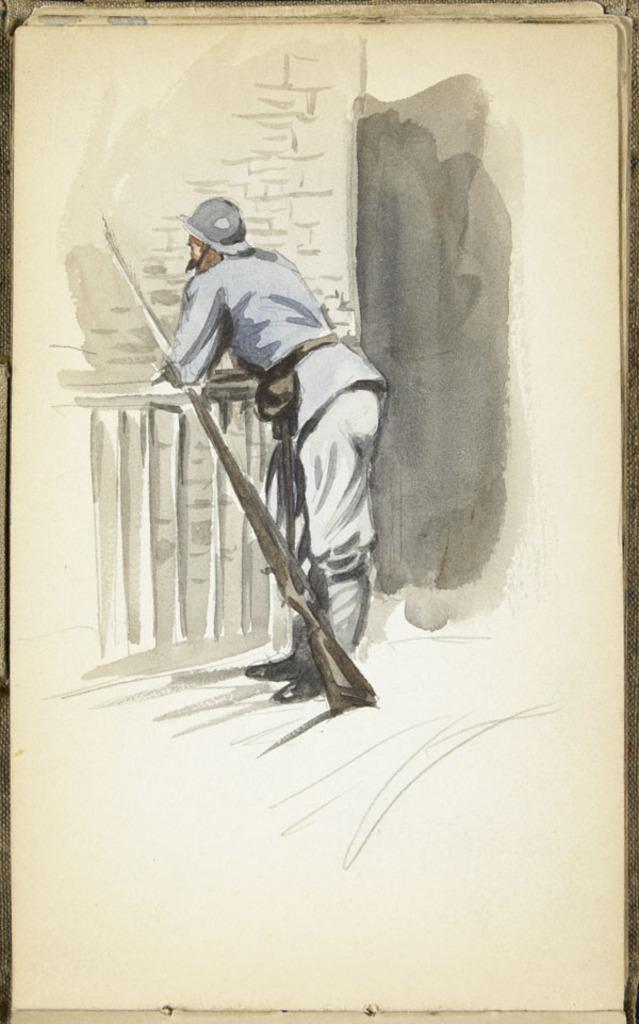How would you summarize this image in a sentence or two? In this image, we can see the painting of a person who is resting his hands on a fencing and there is a gun beside the person and the person is wearing some clothes and shoes. 